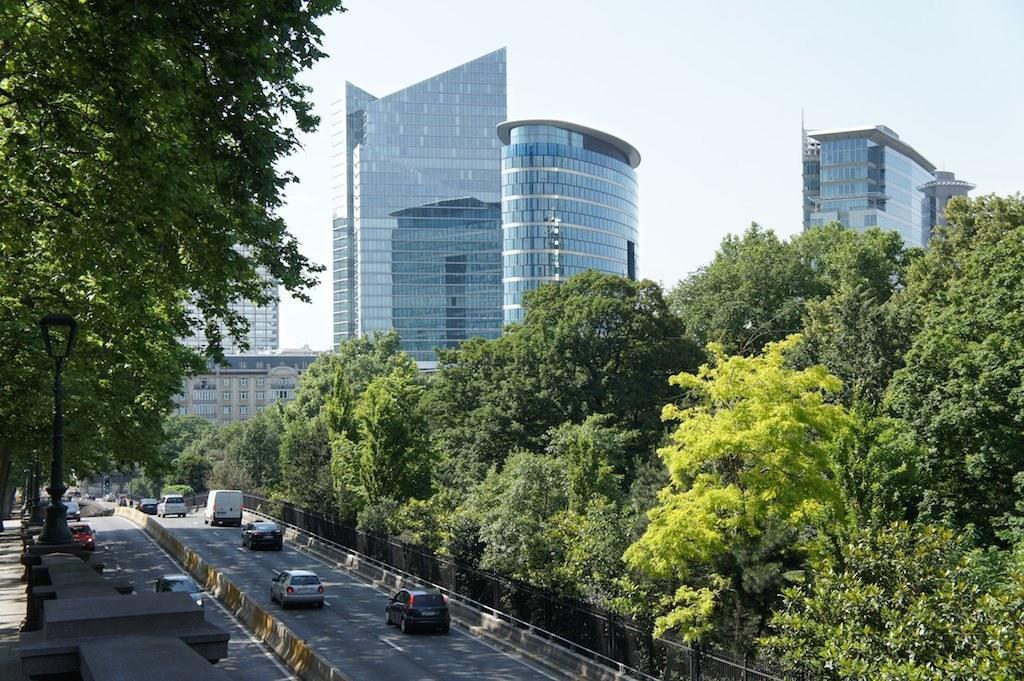Please provide a concise description of this image. In this image at the bottom there is a road, on the road there are some vehicles and on the right side there are some trees, buildings and on the left side there are trees and some vehicles. 